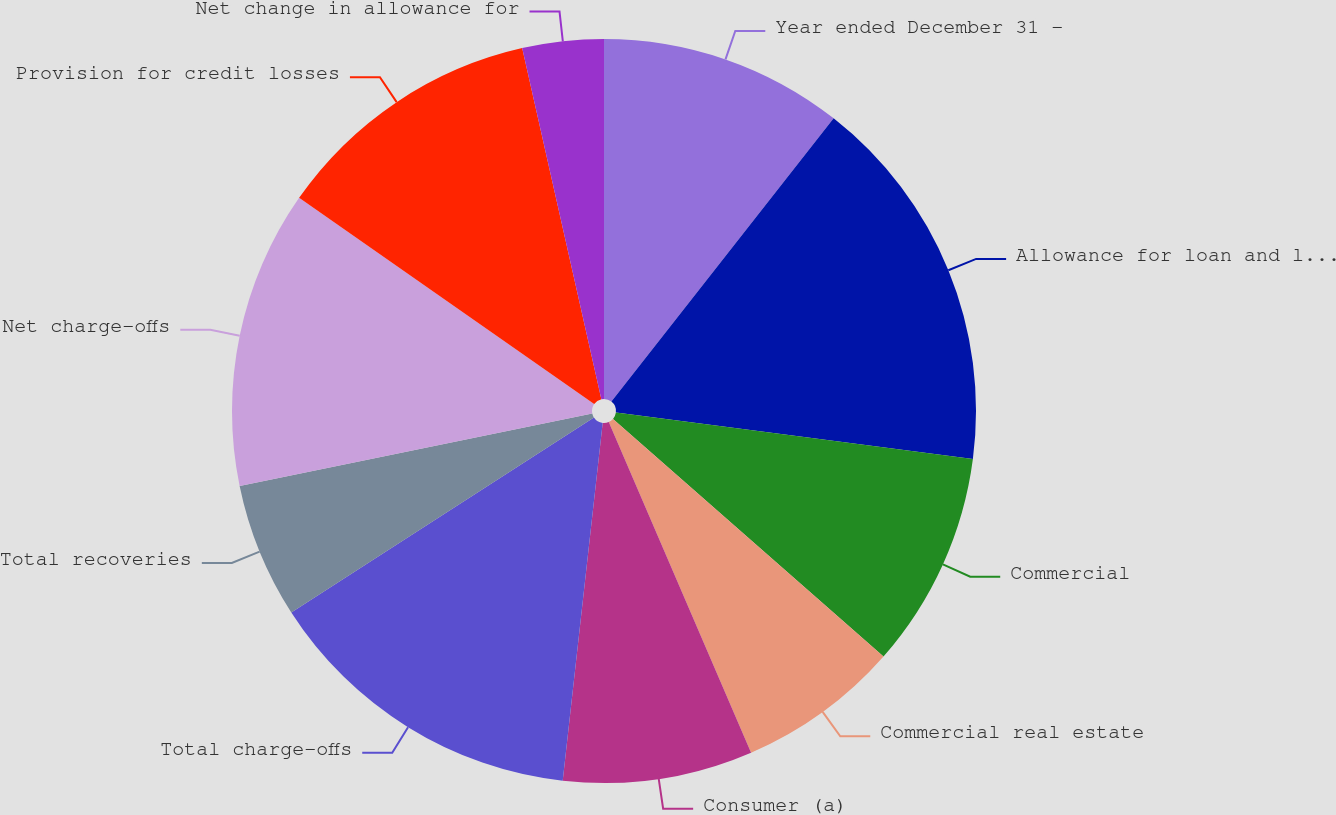Convert chart. <chart><loc_0><loc_0><loc_500><loc_500><pie_chart><fcel>Year ended December 31 -<fcel>Allowance for loan and lease<fcel>Commercial<fcel>Commercial real estate<fcel>Consumer (a)<fcel>Total charge-offs<fcel>Total recoveries<fcel>Net charge-offs<fcel>Provision for credit losses<fcel>Net change in allowance for<nl><fcel>10.59%<fcel>16.47%<fcel>9.41%<fcel>7.06%<fcel>8.24%<fcel>14.12%<fcel>5.88%<fcel>12.94%<fcel>11.76%<fcel>3.53%<nl></chart> 